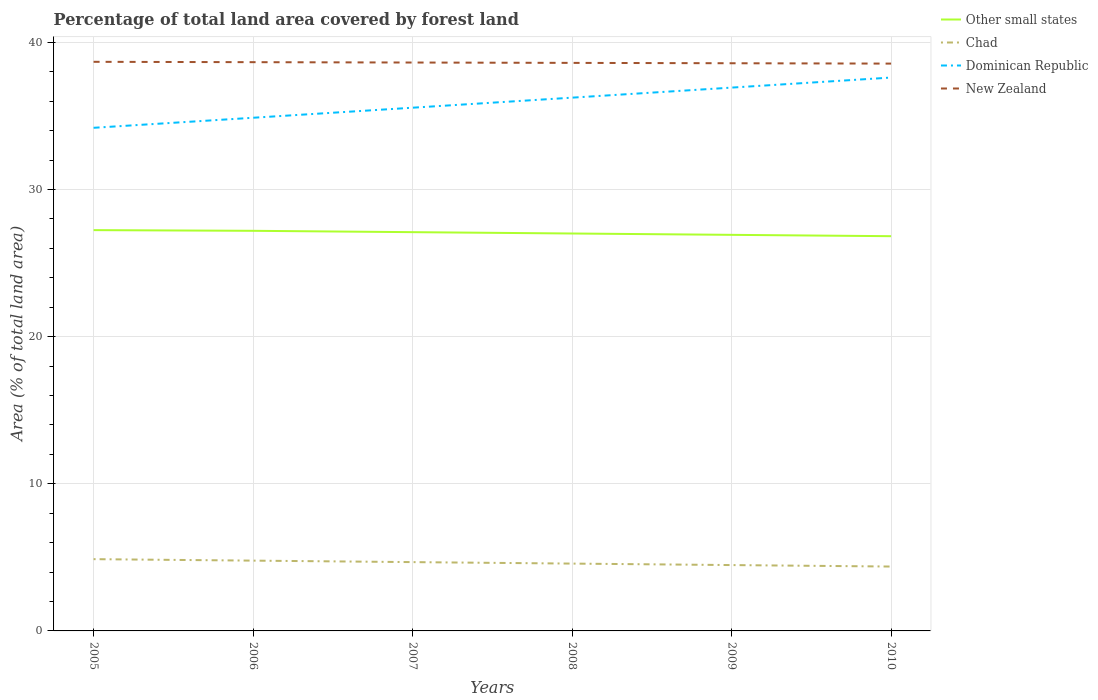How many different coloured lines are there?
Your answer should be compact. 4. Does the line corresponding to Chad intersect with the line corresponding to Dominican Republic?
Ensure brevity in your answer.  No. Is the number of lines equal to the number of legend labels?
Make the answer very short. Yes. Across all years, what is the maximum percentage of forest land in Chad?
Provide a succinct answer. 4.37. What is the total percentage of forest land in Other small states in the graph?
Give a very brief answer. 0.37. What is the difference between the highest and the second highest percentage of forest land in Other small states?
Offer a very short reply. 0.41. Is the percentage of forest land in Dominican Republic strictly greater than the percentage of forest land in Other small states over the years?
Offer a very short reply. No. How many years are there in the graph?
Provide a short and direct response. 6. Are the values on the major ticks of Y-axis written in scientific E-notation?
Keep it short and to the point. No. Does the graph contain any zero values?
Give a very brief answer. No. Does the graph contain grids?
Ensure brevity in your answer.  Yes. Where does the legend appear in the graph?
Give a very brief answer. Top right. How many legend labels are there?
Provide a short and direct response. 4. What is the title of the graph?
Provide a succinct answer. Percentage of total land area covered by forest land. Does "Tonga" appear as one of the legend labels in the graph?
Make the answer very short. No. What is the label or title of the X-axis?
Offer a terse response. Years. What is the label or title of the Y-axis?
Offer a terse response. Area (% of total land area). What is the Area (% of total land area) of Other small states in 2005?
Your response must be concise. 27.24. What is the Area (% of total land area) in Chad in 2005?
Provide a succinct answer. 4.88. What is the Area (% of total land area) of Dominican Republic in 2005?
Provide a succinct answer. 34.19. What is the Area (% of total land area) in New Zealand in 2005?
Keep it short and to the point. 38.67. What is the Area (% of total land area) in Other small states in 2006?
Your response must be concise. 27.19. What is the Area (% of total land area) of Chad in 2006?
Offer a terse response. 4.78. What is the Area (% of total land area) in Dominican Republic in 2006?
Offer a very short reply. 34.87. What is the Area (% of total land area) of New Zealand in 2006?
Your answer should be very brief. 38.65. What is the Area (% of total land area) in Other small states in 2007?
Ensure brevity in your answer.  27.1. What is the Area (% of total land area) in Chad in 2007?
Give a very brief answer. 4.68. What is the Area (% of total land area) of Dominican Republic in 2007?
Provide a short and direct response. 35.55. What is the Area (% of total land area) in New Zealand in 2007?
Offer a very short reply. 38.62. What is the Area (% of total land area) in Other small states in 2008?
Offer a very short reply. 27.01. What is the Area (% of total land area) in Chad in 2008?
Offer a terse response. 4.58. What is the Area (% of total land area) of Dominican Republic in 2008?
Give a very brief answer. 36.24. What is the Area (% of total land area) of New Zealand in 2008?
Keep it short and to the point. 38.6. What is the Area (% of total land area) in Other small states in 2009?
Provide a short and direct response. 26.92. What is the Area (% of total land area) of Chad in 2009?
Ensure brevity in your answer.  4.47. What is the Area (% of total land area) in Dominican Republic in 2009?
Keep it short and to the point. 36.92. What is the Area (% of total land area) in New Zealand in 2009?
Your answer should be compact. 38.58. What is the Area (% of total land area) of Other small states in 2010?
Make the answer very short. 26.82. What is the Area (% of total land area) of Chad in 2010?
Make the answer very short. 4.37. What is the Area (% of total land area) in Dominican Republic in 2010?
Your answer should be very brief. 37.6. What is the Area (% of total land area) in New Zealand in 2010?
Your answer should be very brief. 38.55. Across all years, what is the maximum Area (% of total land area) of Other small states?
Provide a short and direct response. 27.24. Across all years, what is the maximum Area (% of total land area) in Chad?
Ensure brevity in your answer.  4.88. Across all years, what is the maximum Area (% of total land area) of Dominican Republic?
Provide a succinct answer. 37.6. Across all years, what is the maximum Area (% of total land area) in New Zealand?
Give a very brief answer. 38.67. Across all years, what is the minimum Area (% of total land area) of Other small states?
Your response must be concise. 26.82. Across all years, what is the minimum Area (% of total land area) of Chad?
Offer a very short reply. 4.37. Across all years, what is the minimum Area (% of total land area) in Dominican Republic?
Keep it short and to the point. 34.19. Across all years, what is the minimum Area (% of total land area) in New Zealand?
Your response must be concise. 38.55. What is the total Area (% of total land area) in Other small states in the graph?
Offer a terse response. 162.27. What is the total Area (% of total land area) in Chad in the graph?
Give a very brief answer. 27.75. What is the total Area (% of total land area) in Dominican Republic in the graph?
Provide a short and direct response. 215.38. What is the total Area (% of total land area) in New Zealand in the graph?
Offer a very short reply. 231.67. What is the difference between the Area (% of total land area) of Other small states in 2005 and that in 2006?
Offer a terse response. 0.05. What is the difference between the Area (% of total land area) in Chad in 2005 and that in 2006?
Offer a very short reply. 0.1. What is the difference between the Area (% of total land area) of Dominican Republic in 2005 and that in 2006?
Your answer should be very brief. -0.68. What is the difference between the Area (% of total land area) in New Zealand in 2005 and that in 2006?
Ensure brevity in your answer.  0.02. What is the difference between the Area (% of total land area) of Other small states in 2005 and that in 2007?
Your response must be concise. 0.14. What is the difference between the Area (% of total land area) of Chad in 2005 and that in 2007?
Your response must be concise. 0.2. What is the difference between the Area (% of total land area) in Dominican Republic in 2005 and that in 2007?
Your answer should be compact. -1.37. What is the difference between the Area (% of total land area) in New Zealand in 2005 and that in 2007?
Keep it short and to the point. 0.05. What is the difference between the Area (% of total land area) of Other small states in 2005 and that in 2008?
Provide a short and direct response. 0.23. What is the difference between the Area (% of total land area) in Chad in 2005 and that in 2008?
Give a very brief answer. 0.3. What is the difference between the Area (% of total land area) in Dominican Republic in 2005 and that in 2008?
Provide a short and direct response. -2.05. What is the difference between the Area (% of total land area) of New Zealand in 2005 and that in 2008?
Give a very brief answer. 0.07. What is the difference between the Area (% of total land area) of Other small states in 2005 and that in 2009?
Your answer should be compact. 0.32. What is the difference between the Area (% of total land area) of Chad in 2005 and that in 2009?
Your response must be concise. 0.4. What is the difference between the Area (% of total land area) of Dominican Republic in 2005 and that in 2009?
Offer a terse response. -2.73. What is the difference between the Area (% of total land area) of New Zealand in 2005 and that in 2009?
Your answer should be very brief. 0.1. What is the difference between the Area (% of total land area) of Other small states in 2005 and that in 2010?
Offer a very short reply. 0.41. What is the difference between the Area (% of total land area) in Chad in 2005 and that in 2010?
Your answer should be very brief. 0.5. What is the difference between the Area (% of total land area) of Dominican Republic in 2005 and that in 2010?
Ensure brevity in your answer.  -3.41. What is the difference between the Area (% of total land area) of New Zealand in 2005 and that in 2010?
Your response must be concise. 0.12. What is the difference between the Area (% of total land area) of Other small states in 2006 and that in 2007?
Offer a terse response. 0.09. What is the difference between the Area (% of total land area) of Chad in 2006 and that in 2007?
Your answer should be compact. 0.1. What is the difference between the Area (% of total land area) of Dominican Republic in 2006 and that in 2007?
Ensure brevity in your answer.  -0.68. What is the difference between the Area (% of total land area) in New Zealand in 2006 and that in 2007?
Make the answer very short. 0.02. What is the difference between the Area (% of total land area) of Other small states in 2006 and that in 2008?
Ensure brevity in your answer.  0.18. What is the difference between the Area (% of total land area) of Chad in 2006 and that in 2008?
Make the answer very short. 0.2. What is the difference between the Area (% of total land area) of Dominican Republic in 2006 and that in 2008?
Your answer should be very brief. -1.37. What is the difference between the Area (% of total land area) of New Zealand in 2006 and that in 2008?
Ensure brevity in your answer.  0.05. What is the difference between the Area (% of total land area) in Other small states in 2006 and that in 2009?
Provide a short and direct response. 0.27. What is the difference between the Area (% of total land area) of Chad in 2006 and that in 2009?
Your answer should be very brief. 0.3. What is the difference between the Area (% of total land area) in Dominican Republic in 2006 and that in 2009?
Your answer should be very brief. -2.05. What is the difference between the Area (% of total land area) of New Zealand in 2006 and that in 2009?
Provide a succinct answer. 0.07. What is the difference between the Area (% of total land area) of Other small states in 2006 and that in 2010?
Offer a very short reply. 0.36. What is the difference between the Area (% of total land area) in Chad in 2006 and that in 2010?
Provide a succinct answer. 0.4. What is the difference between the Area (% of total land area) of Dominican Republic in 2006 and that in 2010?
Your response must be concise. -2.73. What is the difference between the Area (% of total land area) in New Zealand in 2006 and that in 2010?
Your answer should be very brief. 0.1. What is the difference between the Area (% of total land area) of Other small states in 2007 and that in 2008?
Provide a succinct answer. 0.09. What is the difference between the Area (% of total land area) in Chad in 2007 and that in 2008?
Offer a very short reply. 0.1. What is the difference between the Area (% of total land area) in Dominican Republic in 2007 and that in 2008?
Offer a terse response. -0.68. What is the difference between the Area (% of total land area) in New Zealand in 2007 and that in 2008?
Your response must be concise. 0.02. What is the difference between the Area (% of total land area) of Other small states in 2007 and that in 2009?
Offer a very short reply. 0.18. What is the difference between the Area (% of total land area) in Chad in 2007 and that in 2009?
Make the answer very short. 0.2. What is the difference between the Area (% of total land area) in Dominican Republic in 2007 and that in 2009?
Keep it short and to the point. -1.37. What is the difference between the Area (% of total land area) of New Zealand in 2007 and that in 2009?
Ensure brevity in your answer.  0.05. What is the difference between the Area (% of total land area) in Other small states in 2007 and that in 2010?
Offer a very short reply. 0.27. What is the difference between the Area (% of total land area) of Chad in 2007 and that in 2010?
Ensure brevity in your answer.  0.3. What is the difference between the Area (% of total land area) of Dominican Republic in 2007 and that in 2010?
Make the answer very short. -2.05. What is the difference between the Area (% of total land area) in New Zealand in 2007 and that in 2010?
Your response must be concise. 0.07. What is the difference between the Area (% of total land area) in Other small states in 2008 and that in 2009?
Your answer should be very brief. 0.09. What is the difference between the Area (% of total land area) of Chad in 2008 and that in 2009?
Offer a very short reply. 0.1. What is the difference between the Area (% of total land area) in Dominican Republic in 2008 and that in 2009?
Provide a short and direct response. -0.68. What is the difference between the Area (% of total land area) of New Zealand in 2008 and that in 2009?
Offer a very short reply. 0.02. What is the difference between the Area (% of total land area) of Other small states in 2008 and that in 2010?
Provide a succinct answer. 0.18. What is the difference between the Area (% of total land area) in Chad in 2008 and that in 2010?
Keep it short and to the point. 0.2. What is the difference between the Area (% of total land area) in Dominican Republic in 2008 and that in 2010?
Your answer should be compact. -1.37. What is the difference between the Area (% of total land area) in New Zealand in 2008 and that in 2010?
Your response must be concise. 0.05. What is the difference between the Area (% of total land area) of Other small states in 2009 and that in 2010?
Ensure brevity in your answer.  0.09. What is the difference between the Area (% of total land area) of Chad in 2009 and that in 2010?
Give a very brief answer. 0.1. What is the difference between the Area (% of total land area) of Dominican Republic in 2009 and that in 2010?
Give a very brief answer. -0.68. What is the difference between the Area (% of total land area) of New Zealand in 2009 and that in 2010?
Provide a short and direct response. 0.02. What is the difference between the Area (% of total land area) in Other small states in 2005 and the Area (% of total land area) in Chad in 2006?
Offer a very short reply. 22.46. What is the difference between the Area (% of total land area) of Other small states in 2005 and the Area (% of total land area) of Dominican Republic in 2006?
Offer a very short reply. -7.64. What is the difference between the Area (% of total land area) of Other small states in 2005 and the Area (% of total land area) of New Zealand in 2006?
Keep it short and to the point. -11.41. What is the difference between the Area (% of total land area) in Chad in 2005 and the Area (% of total land area) in Dominican Republic in 2006?
Make the answer very short. -29.99. What is the difference between the Area (% of total land area) in Chad in 2005 and the Area (% of total land area) in New Zealand in 2006?
Provide a succinct answer. -33.77. What is the difference between the Area (% of total land area) of Dominican Republic in 2005 and the Area (% of total land area) of New Zealand in 2006?
Offer a terse response. -4.46. What is the difference between the Area (% of total land area) in Other small states in 2005 and the Area (% of total land area) in Chad in 2007?
Give a very brief answer. 22.56. What is the difference between the Area (% of total land area) in Other small states in 2005 and the Area (% of total land area) in Dominican Republic in 2007?
Keep it short and to the point. -8.32. What is the difference between the Area (% of total land area) in Other small states in 2005 and the Area (% of total land area) in New Zealand in 2007?
Ensure brevity in your answer.  -11.39. What is the difference between the Area (% of total land area) of Chad in 2005 and the Area (% of total land area) of Dominican Republic in 2007?
Provide a succinct answer. -30.68. What is the difference between the Area (% of total land area) of Chad in 2005 and the Area (% of total land area) of New Zealand in 2007?
Your response must be concise. -33.75. What is the difference between the Area (% of total land area) in Dominican Republic in 2005 and the Area (% of total land area) in New Zealand in 2007?
Ensure brevity in your answer.  -4.44. What is the difference between the Area (% of total land area) of Other small states in 2005 and the Area (% of total land area) of Chad in 2008?
Give a very brief answer. 22.66. What is the difference between the Area (% of total land area) of Other small states in 2005 and the Area (% of total land area) of Dominican Republic in 2008?
Ensure brevity in your answer.  -9. What is the difference between the Area (% of total land area) of Other small states in 2005 and the Area (% of total land area) of New Zealand in 2008?
Make the answer very short. -11.36. What is the difference between the Area (% of total land area) of Chad in 2005 and the Area (% of total land area) of Dominican Republic in 2008?
Ensure brevity in your answer.  -31.36. What is the difference between the Area (% of total land area) in Chad in 2005 and the Area (% of total land area) in New Zealand in 2008?
Your answer should be compact. -33.72. What is the difference between the Area (% of total land area) in Dominican Republic in 2005 and the Area (% of total land area) in New Zealand in 2008?
Ensure brevity in your answer.  -4.41. What is the difference between the Area (% of total land area) in Other small states in 2005 and the Area (% of total land area) in Chad in 2009?
Make the answer very short. 22.76. What is the difference between the Area (% of total land area) of Other small states in 2005 and the Area (% of total land area) of Dominican Republic in 2009?
Your answer should be compact. -9.69. What is the difference between the Area (% of total land area) in Other small states in 2005 and the Area (% of total land area) in New Zealand in 2009?
Provide a short and direct response. -11.34. What is the difference between the Area (% of total land area) in Chad in 2005 and the Area (% of total land area) in Dominican Republic in 2009?
Offer a terse response. -32.04. What is the difference between the Area (% of total land area) in Chad in 2005 and the Area (% of total land area) in New Zealand in 2009?
Your answer should be compact. -33.7. What is the difference between the Area (% of total land area) of Dominican Republic in 2005 and the Area (% of total land area) of New Zealand in 2009?
Provide a succinct answer. -4.39. What is the difference between the Area (% of total land area) in Other small states in 2005 and the Area (% of total land area) in Chad in 2010?
Your answer should be compact. 22.86. What is the difference between the Area (% of total land area) of Other small states in 2005 and the Area (% of total land area) of Dominican Republic in 2010?
Your answer should be very brief. -10.37. What is the difference between the Area (% of total land area) in Other small states in 2005 and the Area (% of total land area) in New Zealand in 2010?
Make the answer very short. -11.32. What is the difference between the Area (% of total land area) of Chad in 2005 and the Area (% of total land area) of Dominican Republic in 2010?
Ensure brevity in your answer.  -32.73. What is the difference between the Area (% of total land area) in Chad in 2005 and the Area (% of total land area) in New Zealand in 2010?
Your answer should be compact. -33.67. What is the difference between the Area (% of total land area) in Dominican Republic in 2005 and the Area (% of total land area) in New Zealand in 2010?
Your response must be concise. -4.36. What is the difference between the Area (% of total land area) of Other small states in 2006 and the Area (% of total land area) of Chad in 2007?
Offer a terse response. 22.51. What is the difference between the Area (% of total land area) of Other small states in 2006 and the Area (% of total land area) of Dominican Republic in 2007?
Offer a very short reply. -8.37. What is the difference between the Area (% of total land area) of Other small states in 2006 and the Area (% of total land area) of New Zealand in 2007?
Give a very brief answer. -11.44. What is the difference between the Area (% of total land area) in Chad in 2006 and the Area (% of total land area) in Dominican Republic in 2007?
Your answer should be compact. -30.78. What is the difference between the Area (% of total land area) in Chad in 2006 and the Area (% of total land area) in New Zealand in 2007?
Your answer should be very brief. -33.85. What is the difference between the Area (% of total land area) of Dominican Republic in 2006 and the Area (% of total land area) of New Zealand in 2007?
Offer a terse response. -3.75. What is the difference between the Area (% of total land area) of Other small states in 2006 and the Area (% of total land area) of Chad in 2008?
Your answer should be compact. 22.61. What is the difference between the Area (% of total land area) of Other small states in 2006 and the Area (% of total land area) of Dominican Republic in 2008?
Your answer should be compact. -9.05. What is the difference between the Area (% of total land area) of Other small states in 2006 and the Area (% of total land area) of New Zealand in 2008?
Your answer should be compact. -11.41. What is the difference between the Area (% of total land area) of Chad in 2006 and the Area (% of total land area) of Dominican Republic in 2008?
Give a very brief answer. -31.46. What is the difference between the Area (% of total land area) of Chad in 2006 and the Area (% of total land area) of New Zealand in 2008?
Your response must be concise. -33.82. What is the difference between the Area (% of total land area) of Dominican Republic in 2006 and the Area (% of total land area) of New Zealand in 2008?
Provide a succinct answer. -3.73. What is the difference between the Area (% of total land area) of Other small states in 2006 and the Area (% of total land area) of Chad in 2009?
Your answer should be very brief. 22.71. What is the difference between the Area (% of total land area) of Other small states in 2006 and the Area (% of total land area) of Dominican Republic in 2009?
Ensure brevity in your answer.  -9.73. What is the difference between the Area (% of total land area) in Other small states in 2006 and the Area (% of total land area) in New Zealand in 2009?
Make the answer very short. -11.39. What is the difference between the Area (% of total land area) in Chad in 2006 and the Area (% of total land area) in Dominican Republic in 2009?
Keep it short and to the point. -32.14. What is the difference between the Area (% of total land area) of Chad in 2006 and the Area (% of total land area) of New Zealand in 2009?
Offer a terse response. -33.8. What is the difference between the Area (% of total land area) in Dominican Republic in 2006 and the Area (% of total land area) in New Zealand in 2009?
Keep it short and to the point. -3.7. What is the difference between the Area (% of total land area) in Other small states in 2006 and the Area (% of total land area) in Chad in 2010?
Offer a terse response. 22.81. What is the difference between the Area (% of total land area) in Other small states in 2006 and the Area (% of total land area) in Dominican Republic in 2010?
Give a very brief answer. -10.41. What is the difference between the Area (% of total land area) of Other small states in 2006 and the Area (% of total land area) of New Zealand in 2010?
Offer a very short reply. -11.36. What is the difference between the Area (% of total land area) of Chad in 2006 and the Area (% of total land area) of Dominican Republic in 2010?
Ensure brevity in your answer.  -32.83. What is the difference between the Area (% of total land area) in Chad in 2006 and the Area (% of total land area) in New Zealand in 2010?
Offer a terse response. -33.78. What is the difference between the Area (% of total land area) of Dominican Republic in 2006 and the Area (% of total land area) of New Zealand in 2010?
Offer a terse response. -3.68. What is the difference between the Area (% of total land area) in Other small states in 2007 and the Area (% of total land area) in Chad in 2008?
Keep it short and to the point. 22.52. What is the difference between the Area (% of total land area) in Other small states in 2007 and the Area (% of total land area) in Dominican Republic in 2008?
Your answer should be compact. -9.14. What is the difference between the Area (% of total land area) of Other small states in 2007 and the Area (% of total land area) of New Zealand in 2008?
Give a very brief answer. -11.5. What is the difference between the Area (% of total land area) in Chad in 2007 and the Area (% of total land area) in Dominican Republic in 2008?
Your answer should be very brief. -31.56. What is the difference between the Area (% of total land area) of Chad in 2007 and the Area (% of total land area) of New Zealand in 2008?
Make the answer very short. -33.92. What is the difference between the Area (% of total land area) in Dominican Republic in 2007 and the Area (% of total land area) in New Zealand in 2008?
Your response must be concise. -3.05. What is the difference between the Area (% of total land area) of Other small states in 2007 and the Area (% of total land area) of Chad in 2009?
Make the answer very short. 22.62. What is the difference between the Area (% of total land area) in Other small states in 2007 and the Area (% of total land area) in Dominican Republic in 2009?
Give a very brief answer. -9.82. What is the difference between the Area (% of total land area) of Other small states in 2007 and the Area (% of total land area) of New Zealand in 2009?
Your answer should be very brief. -11.48. What is the difference between the Area (% of total land area) in Chad in 2007 and the Area (% of total land area) in Dominican Republic in 2009?
Provide a succinct answer. -32.24. What is the difference between the Area (% of total land area) of Chad in 2007 and the Area (% of total land area) of New Zealand in 2009?
Your answer should be compact. -33.9. What is the difference between the Area (% of total land area) in Dominican Republic in 2007 and the Area (% of total land area) in New Zealand in 2009?
Provide a short and direct response. -3.02. What is the difference between the Area (% of total land area) of Other small states in 2007 and the Area (% of total land area) of Chad in 2010?
Provide a succinct answer. 22.72. What is the difference between the Area (% of total land area) in Other small states in 2007 and the Area (% of total land area) in Dominican Republic in 2010?
Ensure brevity in your answer.  -10.51. What is the difference between the Area (% of total land area) of Other small states in 2007 and the Area (% of total land area) of New Zealand in 2010?
Ensure brevity in your answer.  -11.45. What is the difference between the Area (% of total land area) of Chad in 2007 and the Area (% of total land area) of Dominican Republic in 2010?
Your response must be concise. -32.93. What is the difference between the Area (% of total land area) of Chad in 2007 and the Area (% of total land area) of New Zealand in 2010?
Offer a very short reply. -33.88. What is the difference between the Area (% of total land area) in Dominican Republic in 2007 and the Area (% of total land area) in New Zealand in 2010?
Keep it short and to the point. -3. What is the difference between the Area (% of total land area) in Other small states in 2008 and the Area (% of total land area) in Chad in 2009?
Keep it short and to the point. 22.53. What is the difference between the Area (% of total land area) in Other small states in 2008 and the Area (% of total land area) in Dominican Republic in 2009?
Your response must be concise. -9.91. What is the difference between the Area (% of total land area) in Other small states in 2008 and the Area (% of total land area) in New Zealand in 2009?
Your answer should be very brief. -11.57. What is the difference between the Area (% of total land area) of Chad in 2008 and the Area (% of total land area) of Dominican Republic in 2009?
Offer a terse response. -32.35. What is the difference between the Area (% of total land area) in Chad in 2008 and the Area (% of total land area) in New Zealand in 2009?
Provide a succinct answer. -34. What is the difference between the Area (% of total land area) in Dominican Republic in 2008 and the Area (% of total land area) in New Zealand in 2009?
Your answer should be very brief. -2.34. What is the difference between the Area (% of total land area) in Other small states in 2008 and the Area (% of total land area) in Chad in 2010?
Keep it short and to the point. 22.63. What is the difference between the Area (% of total land area) of Other small states in 2008 and the Area (% of total land area) of Dominican Republic in 2010?
Keep it short and to the point. -10.6. What is the difference between the Area (% of total land area) in Other small states in 2008 and the Area (% of total land area) in New Zealand in 2010?
Your answer should be very brief. -11.55. What is the difference between the Area (% of total land area) of Chad in 2008 and the Area (% of total land area) of Dominican Republic in 2010?
Keep it short and to the point. -33.03. What is the difference between the Area (% of total land area) in Chad in 2008 and the Area (% of total land area) in New Zealand in 2010?
Keep it short and to the point. -33.98. What is the difference between the Area (% of total land area) in Dominican Republic in 2008 and the Area (% of total land area) in New Zealand in 2010?
Provide a short and direct response. -2.31. What is the difference between the Area (% of total land area) in Other small states in 2009 and the Area (% of total land area) in Chad in 2010?
Your answer should be compact. 22.54. What is the difference between the Area (% of total land area) of Other small states in 2009 and the Area (% of total land area) of Dominican Republic in 2010?
Your answer should be compact. -10.69. What is the difference between the Area (% of total land area) of Other small states in 2009 and the Area (% of total land area) of New Zealand in 2010?
Offer a terse response. -11.64. What is the difference between the Area (% of total land area) in Chad in 2009 and the Area (% of total land area) in Dominican Republic in 2010?
Make the answer very short. -33.13. What is the difference between the Area (% of total land area) in Chad in 2009 and the Area (% of total land area) in New Zealand in 2010?
Provide a short and direct response. -34.08. What is the difference between the Area (% of total land area) in Dominican Republic in 2009 and the Area (% of total land area) in New Zealand in 2010?
Ensure brevity in your answer.  -1.63. What is the average Area (% of total land area) in Other small states per year?
Ensure brevity in your answer.  27.04. What is the average Area (% of total land area) of Chad per year?
Make the answer very short. 4.63. What is the average Area (% of total land area) in Dominican Republic per year?
Your answer should be very brief. 35.9. What is the average Area (% of total land area) of New Zealand per year?
Offer a very short reply. 38.61. In the year 2005, what is the difference between the Area (% of total land area) in Other small states and Area (% of total land area) in Chad?
Offer a very short reply. 22.36. In the year 2005, what is the difference between the Area (% of total land area) in Other small states and Area (% of total land area) in Dominican Republic?
Provide a succinct answer. -6.95. In the year 2005, what is the difference between the Area (% of total land area) in Other small states and Area (% of total land area) in New Zealand?
Offer a terse response. -11.44. In the year 2005, what is the difference between the Area (% of total land area) of Chad and Area (% of total land area) of Dominican Republic?
Offer a very short reply. -29.31. In the year 2005, what is the difference between the Area (% of total land area) in Chad and Area (% of total land area) in New Zealand?
Provide a short and direct response. -33.8. In the year 2005, what is the difference between the Area (% of total land area) in Dominican Republic and Area (% of total land area) in New Zealand?
Make the answer very short. -4.48. In the year 2006, what is the difference between the Area (% of total land area) in Other small states and Area (% of total land area) in Chad?
Provide a succinct answer. 22.41. In the year 2006, what is the difference between the Area (% of total land area) in Other small states and Area (% of total land area) in Dominican Republic?
Ensure brevity in your answer.  -7.68. In the year 2006, what is the difference between the Area (% of total land area) of Other small states and Area (% of total land area) of New Zealand?
Offer a very short reply. -11.46. In the year 2006, what is the difference between the Area (% of total land area) of Chad and Area (% of total land area) of Dominican Republic?
Offer a terse response. -30.1. In the year 2006, what is the difference between the Area (% of total land area) of Chad and Area (% of total land area) of New Zealand?
Ensure brevity in your answer.  -33.87. In the year 2006, what is the difference between the Area (% of total land area) in Dominican Republic and Area (% of total land area) in New Zealand?
Provide a short and direct response. -3.78. In the year 2007, what is the difference between the Area (% of total land area) in Other small states and Area (% of total land area) in Chad?
Offer a terse response. 22.42. In the year 2007, what is the difference between the Area (% of total land area) in Other small states and Area (% of total land area) in Dominican Republic?
Offer a very short reply. -8.46. In the year 2007, what is the difference between the Area (% of total land area) in Other small states and Area (% of total land area) in New Zealand?
Offer a very short reply. -11.53. In the year 2007, what is the difference between the Area (% of total land area) in Chad and Area (% of total land area) in Dominican Republic?
Provide a succinct answer. -30.88. In the year 2007, what is the difference between the Area (% of total land area) of Chad and Area (% of total land area) of New Zealand?
Make the answer very short. -33.95. In the year 2007, what is the difference between the Area (% of total land area) of Dominican Republic and Area (% of total land area) of New Zealand?
Provide a short and direct response. -3.07. In the year 2008, what is the difference between the Area (% of total land area) in Other small states and Area (% of total land area) in Chad?
Make the answer very short. 22.43. In the year 2008, what is the difference between the Area (% of total land area) of Other small states and Area (% of total land area) of Dominican Republic?
Make the answer very short. -9.23. In the year 2008, what is the difference between the Area (% of total land area) in Other small states and Area (% of total land area) in New Zealand?
Keep it short and to the point. -11.59. In the year 2008, what is the difference between the Area (% of total land area) in Chad and Area (% of total land area) in Dominican Republic?
Your answer should be compact. -31.66. In the year 2008, what is the difference between the Area (% of total land area) of Chad and Area (% of total land area) of New Zealand?
Make the answer very short. -34.02. In the year 2008, what is the difference between the Area (% of total land area) of Dominican Republic and Area (% of total land area) of New Zealand?
Your response must be concise. -2.36. In the year 2009, what is the difference between the Area (% of total land area) in Other small states and Area (% of total land area) in Chad?
Keep it short and to the point. 22.44. In the year 2009, what is the difference between the Area (% of total land area) of Other small states and Area (% of total land area) of Dominican Republic?
Your response must be concise. -10.01. In the year 2009, what is the difference between the Area (% of total land area) of Other small states and Area (% of total land area) of New Zealand?
Make the answer very short. -11.66. In the year 2009, what is the difference between the Area (% of total land area) of Chad and Area (% of total land area) of Dominican Republic?
Your answer should be compact. -32.45. In the year 2009, what is the difference between the Area (% of total land area) in Chad and Area (% of total land area) in New Zealand?
Keep it short and to the point. -34.1. In the year 2009, what is the difference between the Area (% of total land area) in Dominican Republic and Area (% of total land area) in New Zealand?
Make the answer very short. -1.66. In the year 2010, what is the difference between the Area (% of total land area) of Other small states and Area (% of total land area) of Chad?
Offer a very short reply. 22.45. In the year 2010, what is the difference between the Area (% of total land area) of Other small states and Area (% of total land area) of Dominican Republic?
Offer a very short reply. -10.78. In the year 2010, what is the difference between the Area (% of total land area) of Other small states and Area (% of total land area) of New Zealand?
Ensure brevity in your answer.  -11.73. In the year 2010, what is the difference between the Area (% of total land area) of Chad and Area (% of total land area) of Dominican Republic?
Make the answer very short. -33.23. In the year 2010, what is the difference between the Area (% of total land area) of Chad and Area (% of total land area) of New Zealand?
Your response must be concise. -34.18. In the year 2010, what is the difference between the Area (% of total land area) in Dominican Republic and Area (% of total land area) in New Zealand?
Your answer should be very brief. -0.95. What is the ratio of the Area (% of total land area) of Dominican Republic in 2005 to that in 2006?
Your answer should be very brief. 0.98. What is the ratio of the Area (% of total land area) of Chad in 2005 to that in 2007?
Offer a very short reply. 1.04. What is the ratio of the Area (% of total land area) of Dominican Republic in 2005 to that in 2007?
Make the answer very short. 0.96. What is the ratio of the Area (% of total land area) of New Zealand in 2005 to that in 2007?
Offer a terse response. 1. What is the ratio of the Area (% of total land area) of Other small states in 2005 to that in 2008?
Offer a terse response. 1.01. What is the ratio of the Area (% of total land area) of Chad in 2005 to that in 2008?
Provide a succinct answer. 1.07. What is the ratio of the Area (% of total land area) of Dominican Republic in 2005 to that in 2008?
Offer a terse response. 0.94. What is the ratio of the Area (% of total land area) of New Zealand in 2005 to that in 2008?
Keep it short and to the point. 1. What is the ratio of the Area (% of total land area) of Other small states in 2005 to that in 2009?
Provide a short and direct response. 1.01. What is the ratio of the Area (% of total land area) in Chad in 2005 to that in 2009?
Offer a very short reply. 1.09. What is the ratio of the Area (% of total land area) in Dominican Republic in 2005 to that in 2009?
Offer a terse response. 0.93. What is the ratio of the Area (% of total land area) in Other small states in 2005 to that in 2010?
Your answer should be compact. 1.02. What is the ratio of the Area (% of total land area) of Chad in 2005 to that in 2010?
Offer a very short reply. 1.11. What is the ratio of the Area (% of total land area) of Dominican Republic in 2005 to that in 2010?
Make the answer very short. 0.91. What is the ratio of the Area (% of total land area) of Other small states in 2006 to that in 2007?
Give a very brief answer. 1. What is the ratio of the Area (% of total land area) in Chad in 2006 to that in 2007?
Provide a succinct answer. 1.02. What is the ratio of the Area (% of total land area) in Dominican Republic in 2006 to that in 2007?
Your answer should be compact. 0.98. What is the ratio of the Area (% of total land area) in New Zealand in 2006 to that in 2007?
Give a very brief answer. 1. What is the ratio of the Area (% of total land area) of Other small states in 2006 to that in 2008?
Ensure brevity in your answer.  1.01. What is the ratio of the Area (% of total land area) of Chad in 2006 to that in 2008?
Keep it short and to the point. 1.04. What is the ratio of the Area (% of total land area) in Dominican Republic in 2006 to that in 2008?
Your response must be concise. 0.96. What is the ratio of the Area (% of total land area) in Other small states in 2006 to that in 2009?
Offer a very short reply. 1.01. What is the ratio of the Area (% of total land area) of Chad in 2006 to that in 2009?
Provide a short and direct response. 1.07. What is the ratio of the Area (% of total land area) in Dominican Republic in 2006 to that in 2009?
Provide a succinct answer. 0.94. What is the ratio of the Area (% of total land area) in New Zealand in 2006 to that in 2009?
Provide a succinct answer. 1. What is the ratio of the Area (% of total land area) of Other small states in 2006 to that in 2010?
Give a very brief answer. 1.01. What is the ratio of the Area (% of total land area) in Chad in 2006 to that in 2010?
Your answer should be very brief. 1.09. What is the ratio of the Area (% of total land area) of Dominican Republic in 2006 to that in 2010?
Provide a short and direct response. 0.93. What is the ratio of the Area (% of total land area) in New Zealand in 2006 to that in 2010?
Offer a terse response. 1. What is the ratio of the Area (% of total land area) in Other small states in 2007 to that in 2008?
Ensure brevity in your answer.  1. What is the ratio of the Area (% of total land area) of Dominican Republic in 2007 to that in 2008?
Your answer should be very brief. 0.98. What is the ratio of the Area (% of total land area) in New Zealand in 2007 to that in 2008?
Provide a short and direct response. 1. What is the ratio of the Area (% of total land area) in Other small states in 2007 to that in 2009?
Your answer should be compact. 1.01. What is the ratio of the Area (% of total land area) in Chad in 2007 to that in 2009?
Provide a short and direct response. 1.04. What is the ratio of the Area (% of total land area) of New Zealand in 2007 to that in 2009?
Offer a very short reply. 1. What is the ratio of the Area (% of total land area) of Other small states in 2007 to that in 2010?
Offer a very short reply. 1.01. What is the ratio of the Area (% of total land area) of Chad in 2007 to that in 2010?
Keep it short and to the point. 1.07. What is the ratio of the Area (% of total land area) in Dominican Republic in 2007 to that in 2010?
Your answer should be compact. 0.95. What is the ratio of the Area (% of total land area) in New Zealand in 2007 to that in 2010?
Offer a terse response. 1. What is the ratio of the Area (% of total land area) in Chad in 2008 to that in 2009?
Your response must be concise. 1.02. What is the ratio of the Area (% of total land area) of Dominican Republic in 2008 to that in 2009?
Provide a succinct answer. 0.98. What is the ratio of the Area (% of total land area) in Other small states in 2008 to that in 2010?
Give a very brief answer. 1.01. What is the ratio of the Area (% of total land area) of Chad in 2008 to that in 2010?
Your answer should be very brief. 1.05. What is the ratio of the Area (% of total land area) in Dominican Republic in 2008 to that in 2010?
Provide a short and direct response. 0.96. What is the ratio of the Area (% of total land area) of New Zealand in 2008 to that in 2010?
Provide a short and direct response. 1. What is the ratio of the Area (% of total land area) in Other small states in 2009 to that in 2010?
Keep it short and to the point. 1. What is the ratio of the Area (% of total land area) in Dominican Republic in 2009 to that in 2010?
Your answer should be very brief. 0.98. What is the difference between the highest and the second highest Area (% of total land area) in Other small states?
Your response must be concise. 0.05. What is the difference between the highest and the second highest Area (% of total land area) of Chad?
Your answer should be compact. 0.1. What is the difference between the highest and the second highest Area (% of total land area) of Dominican Republic?
Your response must be concise. 0.68. What is the difference between the highest and the second highest Area (% of total land area) in New Zealand?
Ensure brevity in your answer.  0.02. What is the difference between the highest and the lowest Area (% of total land area) in Other small states?
Give a very brief answer. 0.41. What is the difference between the highest and the lowest Area (% of total land area) of Chad?
Provide a succinct answer. 0.5. What is the difference between the highest and the lowest Area (% of total land area) in Dominican Republic?
Your response must be concise. 3.41. What is the difference between the highest and the lowest Area (% of total land area) in New Zealand?
Offer a very short reply. 0.12. 